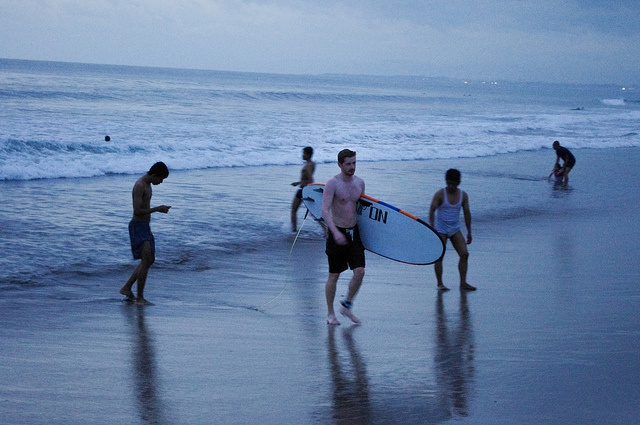Describe the objects in this image and their specific colors. I can see people in darkgray, black, purple, and gray tones, surfboard in darkgray, gray, blue, black, and navy tones, people in darkgray, black, navy, gray, and blue tones, people in darkgray, black, and gray tones, and people in darkgray, black, gray, navy, and purple tones in this image. 